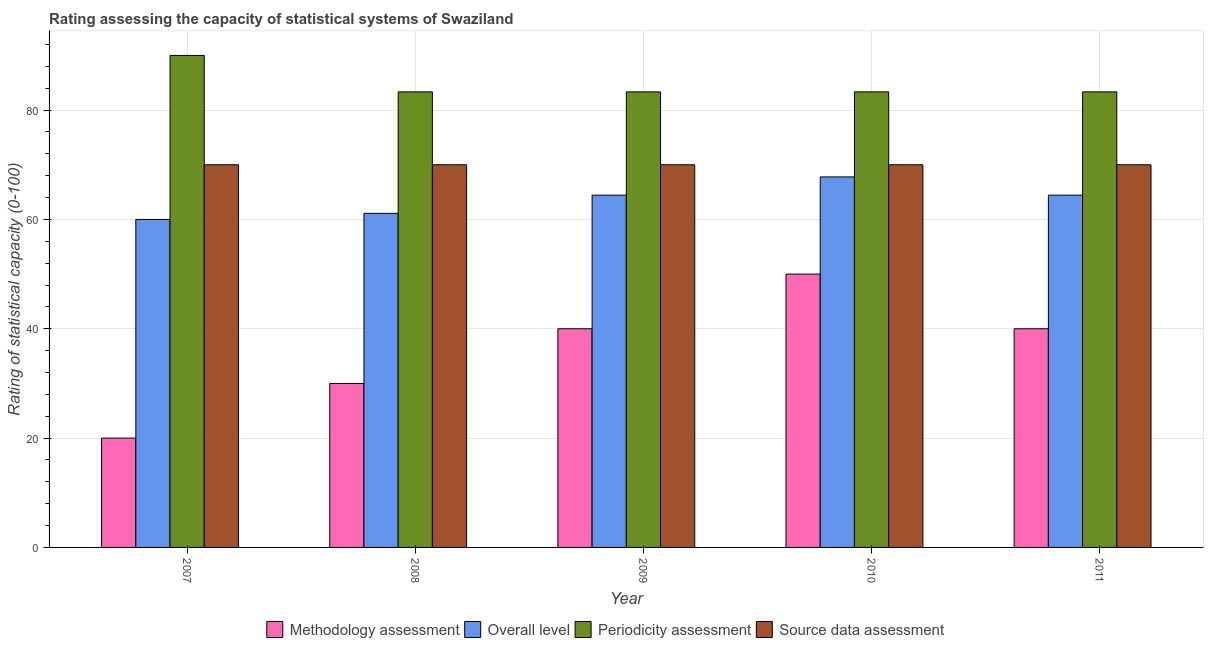How many groups of bars are there?
Ensure brevity in your answer.  5. Are the number of bars per tick equal to the number of legend labels?
Your response must be concise. Yes. How many bars are there on the 3rd tick from the left?
Ensure brevity in your answer.  4. How many bars are there on the 5th tick from the right?
Offer a terse response. 4. What is the label of the 2nd group of bars from the left?
Keep it short and to the point. 2008. What is the periodicity assessment rating in 2008?
Provide a short and direct response. 83.33. Across all years, what is the maximum overall level rating?
Make the answer very short. 67.78. Across all years, what is the minimum periodicity assessment rating?
Offer a very short reply. 83.33. In which year was the methodology assessment rating minimum?
Offer a very short reply. 2007. What is the total overall level rating in the graph?
Make the answer very short. 317.78. What is the difference between the overall level rating in 2008 and that in 2009?
Give a very brief answer. -3.33. In the year 2008, what is the difference between the source data assessment rating and overall level rating?
Offer a very short reply. 0. In how many years, is the methodology assessment rating greater than 52?
Your response must be concise. 0. What is the ratio of the overall level rating in 2009 to that in 2010?
Offer a terse response. 0.95. Is the methodology assessment rating in 2007 less than that in 2010?
Make the answer very short. Yes. Is the difference between the overall level rating in 2007 and 2009 greater than the difference between the methodology assessment rating in 2007 and 2009?
Provide a succinct answer. No. What is the difference between the highest and the second highest source data assessment rating?
Keep it short and to the point. 0. What is the difference between the highest and the lowest methodology assessment rating?
Provide a short and direct response. 30. In how many years, is the source data assessment rating greater than the average source data assessment rating taken over all years?
Ensure brevity in your answer.  0. What does the 2nd bar from the left in 2011 represents?
Make the answer very short. Overall level. What does the 1st bar from the right in 2008 represents?
Provide a succinct answer. Source data assessment. Is it the case that in every year, the sum of the methodology assessment rating and overall level rating is greater than the periodicity assessment rating?
Ensure brevity in your answer.  No. How many bars are there?
Your response must be concise. 20. Are all the bars in the graph horizontal?
Provide a short and direct response. No. How many years are there in the graph?
Give a very brief answer. 5. Does the graph contain any zero values?
Make the answer very short. No. Where does the legend appear in the graph?
Your response must be concise. Bottom center. How many legend labels are there?
Your response must be concise. 4. How are the legend labels stacked?
Give a very brief answer. Horizontal. What is the title of the graph?
Provide a succinct answer. Rating assessing the capacity of statistical systems of Swaziland. What is the label or title of the Y-axis?
Make the answer very short. Rating of statistical capacity (0-100). What is the Rating of statistical capacity (0-100) of Methodology assessment in 2007?
Ensure brevity in your answer.  20. What is the Rating of statistical capacity (0-100) of Overall level in 2007?
Offer a terse response. 60. What is the Rating of statistical capacity (0-100) in Methodology assessment in 2008?
Offer a very short reply. 30. What is the Rating of statistical capacity (0-100) of Overall level in 2008?
Your response must be concise. 61.11. What is the Rating of statistical capacity (0-100) of Periodicity assessment in 2008?
Your response must be concise. 83.33. What is the Rating of statistical capacity (0-100) in Overall level in 2009?
Make the answer very short. 64.44. What is the Rating of statistical capacity (0-100) of Periodicity assessment in 2009?
Provide a succinct answer. 83.33. What is the Rating of statistical capacity (0-100) of Source data assessment in 2009?
Your answer should be compact. 70. What is the Rating of statistical capacity (0-100) in Methodology assessment in 2010?
Give a very brief answer. 50. What is the Rating of statistical capacity (0-100) of Overall level in 2010?
Your answer should be very brief. 67.78. What is the Rating of statistical capacity (0-100) in Periodicity assessment in 2010?
Give a very brief answer. 83.33. What is the Rating of statistical capacity (0-100) in Source data assessment in 2010?
Make the answer very short. 70. What is the Rating of statistical capacity (0-100) in Overall level in 2011?
Offer a very short reply. 64.44. What is the Rating of statistical capacity (0-100) of Periodicity assessment in 2011?
Keep it short and to the point. 83.33. What is the Rating of statistical capacity (0-100) of Source data assessment in 2011?
Provide a short and direct response. 70. Across all years, what is the maximum Rating of statistical capacity (0-100) in Overall level?
Your answer should be compact. 67.78. Across all years, what is the minimum Rating of statistical capacity (0-100) of Overall level?
Provide a succinct answer. 60. Across all years, what is the minimum Rating of statistical capacity (0-100) in Periodicity assessment?
Make the answer very short. 83.33. Across all years, what is the minimum Rating of statistical capacity (0-100) of Source data assessment?
Keep it short and to the point. 70. What is the total Rating of statistical capacity (0-100) of Methodology assessment in the graph?
Keep it short and to the point. 180. What is the total Rating of statistical capacity (0-100) in Overall level in the graph?
Offer a terse response. 317.78. What is the total Rating of statistical capacity (0-100) in Periodicity assessment in the graph?
Ensure brevity in your answer.  423.33. What is the total Rating of statistical capacity (0-100) in Source data assessment in the graph?
Offer a terse response. 350. What is the difference between the Rating of statistical capacity (0-100) in Overall level in 2007 and that in 2008?
Give a very brief answer. -1.11. What is the difference between the Rating of statistical capacity (0-100) in Source data assessment in 2007 and that in 2008?
Provide a short and direct response. 0. What is the difference between the Rating of statistical capacity (0-100) of Methodology assessment in 2007 and that in 2009?
Offer a very short reply. -20. What is the difference between the Rating of statistical capacity (0-100) of Overall level in 2007 and that in 2009?
Your response must be concise. -4.44. What is the difference between the Rating of statistical capacity (0-100) in Periodicity assessment in 2007 and that in 2009?
Make the answer very short. 6.67. What is the difference between the Rating of statistical capacity (0-100) in Overall level in 2007 and that in 2010?
Your answer should be compact. -7.78. What is the difference between the Rating of statistical capacity (0-100) in Periodicity assessment in 2007 and that in 2010?
Your answer should be very brief. 6.67. What is the difference between the Rating of statistical capacity (0-100) in Source data assessment in 2007 and that in 2010?
Provide a short and direct response. 0. What is the difference between the Rating of statistical capacity (0-100) of Methodology assessment in 2007 and that in 2011?
Your answer should be compact. -20. What is the difference between the Rating of statistical capacity (0-100) in Overall level in 2007 and that in 2011?
Your response must be concise. -4.44. What is the difference between the Rating of statistical capacity (0-100) in Source data assessment in 2007 and that in 2011?
Offer a terse response. 0. What is the difference between the Rating of statistical capacity (0-100) of Overall level in 2008 and that in 2009?
Ensure brevity in your answer.  -3.33. What is the difference between the Rating of statistical capacity (0-100) of Periodicity assessment in 2008 and that in 2009?
Offer a very short reply. 0. What is the difference between the Rating of statistical capacity (0-100) in Methodology assessment in 2008 and that in 2010?
Provide a short and direct response. -20. What is the difference between the Rating of statistical capacity (0-100) of Overall level in 2008 and that in 2010?
Your answer should be very brief. -6.67. What is the difference between the Rating of statistical capacity (0-100) of Periodicity assessment in 2008 and that in 2010?
Offer a very short reply. 0. What is the difference between the Rating of statistical capacity (0-100) of Methodology assessment in 2008 and that in 2011?
Your answer should be very brief. -10. What is the difference between the Rating of statistical capacity (0-100) of Source data assessment in 2008 and that in 2011?
Ensure brevity in your answer.  0. What is the difference between the Rating of statistical capacity (0-100) of Source data assessment in 2009 and that in 2010?
Give a very brief answer. 0. What is the difference between the Rating of statistical capacity (0-100) of Overall level in 2009 and that in 2011?
Keep it short and to the point. 0. What is the difference between the Rating of statistical capacity (0-100) of Methodology assessment in 2010 and that in 2011?
Offer a very short reply. 10. What is the difference between the Rating of statistical capacity (0-100) in Overall level in 2010 and that in 2011?
Your answer should be very brief. 3.33. What is the difference between the Rating of statistical capacity (0-100) of Methodology assessment in 2007 and the Rating of statistical capacity (0-100) of Overall level in 2008?
Your response must be concise. -41.11. What is the difference between the Rating of statistical capacity (0-100) in Methodology assessment in 2007 and the Rating of statistical capacity (0-100) in Periodicity assessment in 2008?
Provide a succinct answer. -63.33. What is the difference between the Rating of statistical capacity (0-100) of Overall level in 2007 and the Rating of statistical capacity (0-100) of Periodicity assessment in 2008?
Keep it short and to the point. -23.33. What is the difference between the Rating of statistical capacity (0-100) of Overall level in 2007 and the Rating of statistical capacity (0-100) of Source data assessment in 2008?
Ensure brevity in your answer.  -10. What is the difference between the Rating of statistical capacity (0-100) in Periodicity assessment in 2007 and the Rating of statistical capacity (0-100) in Source data assessment in 2008?
Your answer should be compact. 20. What is the difference between the Rating of statistical capacity (0-100) of Methodology assessment in 2007 and the Rating of statistical capacity (0-100) of Overall level in 2009?
Provide a short and direct response. -44.44. What is the difference between the Rating of statistical capacity (0-100) in Methodology assessment in 2007 and the Rating of statistical capacity (0-100) in Periodicity assessment in 2009?
Offer a very short reply. -63.33. What is the difference between the Rating of statistical capacity (0-100) in Methodology assessment in 2007 and the Rating of statistical capacity (0-100) in Source data assessment in 2009?
Ensure brevity in your answer.  -50. What is the difference between the Rating of statistical capacity (0-100) of Overall level in 2007 and the Rating of statistical capacity (0-100) of Periodicity assessment in 2009?
Keep it short and to the point. -23.33. What is the difference between the Rating of statistical capacity (0-100) in Periodicity assessment in 2007 and the Rating of statistical capacity (0-100) in Source data assessment in 2009?
Your answer should be very brief. 20. What is the difference between the Rating of statistical capacity (0-100) in Methodology assessment in 2007 and the Rating of statistical capacity (0-100) in Overall level in 2010?
Your response must be concise. -47.78. What is the difference between the Rating of statistical capacity (0-100) of Methodology assessment in 2007 and the Rating of statistical capacity (0-100) of Periodicity assessment in 2010?
Make the answer very short. -63.33. What is the difference between the Rating of statistical capacity (0-100) of Overall level in 2007 and the Rating of statistical capacity (0-100) of Periodicity assessment in 2010?
Offer a very short reply. -23.33. What is the difference between the Rating of statistical capacity (0-100) of Periodicity assessment in 2007 and the Rating of statistical capacity (0-100) of Source data assessment in 2010?
Offer a terse response. 20. What is the difference between the Rating of statistical capacity (0-100) of Methodology assessment in 2007 and the Rating of statistical capacity (0-100) of Overall level in 2011?
Offer a terse response. -44.44. What is the difference between the Rating of statistical capacity (0-100) in Methodology assessment in 2007 and the Rating of statistical capacity (0-100) in Periodicity assessment in 2011?
Provide a short and direct response. -63.33. What is the difference between the Rating of statistical capacity (0-100) in Methodology assessment in 2007 and the Rating of statistical capacity (0-100) in Source data assessment in 2011?
Your answer should be very brief. -50. What is the difference between the Rating of statistical capacity (0-100) in Overall level in 2007 and the Rating of statistical capacity (0-100) in Periodicity assessment in 2011?
Your answer should be compact. -23.33. What is the difference between the Rating of statistical capacity (0-100) of Overall level in 2007 and the Rating of statistical capacity (0-100) of Source data assessment in 2011?
Your answer should be very brief. -10. What is the difference between the Rating of statistical capacity (0-100) of Methodology assessment in 2008 and the Rating of statistical capacity (0-100) of Overall level in 2009?
Give a very brief answer. -34.44. What is the difference between the Rating of statistical capacity (0-100) in Methodology assessment in 2008 and the Rating of statistical capacity (0-100) in Periodicity assessment in 2009?
Keep it short and to the point. -53.33. What is the difference between the Rating of statistical capacity (0-100) of Overall level in 2008 and the Rating of statistical capacity (0-100) of Periodicity assessment in 2009?
Offer a very short reply. -22.22. What is the difference between the Rating of statistical capacity (0-100) in Overall level in 2008 and the Rating of statistical capacity (0-100) in Source data assessment in 2009?
Your answer should be compact. -8.89. What is the difference between the Rating of statistical capacity (0-100) of Periodicity assessment in 2008 and the Rating of statistical capacity (0-100) of Source data assessment in 2009?
Your answer should be compact. 13.33. What is the difference between the Rating of statistical capacity (0-100) in Methodology assessment in 2008 and the Rating of statistical capacity (0-100) in Overall level in 2010?
Ensure brevity in your answer.  -37.78. What is the difference between the Rating of statistical capacity (0-100) in Methodology assessment in 2008 and the Rating of statistical capacity (0-100) in Periodicity assessment in 2010?
Offer a very short reply. -53.33. What is the difference between the Rating of statistical capacity (0-100) of Overall level in 2008 and the Rating of statistical capacity (0-100) of Periodicity assessment in 2010?
Your response must be concise. -22.22. What is the difference between the Rating of statistical capacity (0-100) of Overall level in 2008 and the Rating of statistical capacity (0-100) of Source data assessment in 2010?
Ensure brevity in your answer.  -8.89. What is the difference between the Rating of statistical capacity (0-100) in Periodicity assessment in 2008 and the Rating of statistical capacity (0-100) in Source data assessment in 2010?
Provide a succinct answer. 13.33. What is the difference between the Rating of statistical capacity (0-100) in Methodology assessment in 2008 and the Rating of statistical capacity (0-100) in Overall level in 2011?
Offer a very short reply. -34.44. What is the difference between the Rating of statistical capacity (0-100) in Methodology assessment in 2008 and the Rating of statistical capacity (0-100) in Periodicity assessment in 2011?
Ensure brevity in your answer.  -53.33. What is the difference between the Rating of statistical capacity (0-100) of Methodology assessment in 2008 and the Rating of statistical capacity (0-100) of Source data assessment in 2011?
Ensure brevity in your answer.  -40. What is the difference between the Rating of statistical capacity (0-100) in Overall level in 2008 and the Rating of statistical capacity (0-100) in Periodicity assessment in 2011?
Provide a succinct answer. -22.22. What is the difference between the Rating of statistical capacity (0-100) of Overall level in 2008 and the Rating of statistical capacity (0-100) of Source data assessment in 2011?
Offer a terse response. -8.89. What is the difference between the Rating of statistical capacity (0-100) in Periodicity assessment in 2008 and the Rating of statistical capacity (0-100) in Source data assessment in 2011?
Keep it short and to the point. 13.33. What is the difference between the Rating of statistical capacity (0-100) of Methodology assessment in 2009 and the Rating of statistical capacity (0-100) of Overall level in 2010?
Give a very brief answer. -27.78. What is the difference between the Rating of statistical capacity (0-100) of Methodology assessment in 2009 and the Rating of statistical capacity (0-100) of Periodicity assessment in 2010?
Offer a terse response. -43.33. What is the difference between the Rating of statistical capacity (0-100) of Overall level in 2009 and the Rating of statistical capacity (0-100) of Periodicity assessment in 2010?
Offer a terse response. -18.89. What is the difference between the Rating of statistical capacity (0-100) of Overall level in 2009 and the Rating of statistical capacity (0-100) of Source data assessment in 2010?
Provide a short and direct response. -5.56. What is the difference between the Rating of statistical capacity (0-100) in Periodicity assessment in 2009 and the Rating of statistical capacity (0-100) in Source data assessment in 2010?
Make the answer very short. 13.33. What is the difference between the Rating of statistical capacity (0-100) in Methodology assessment in 2009 and the Rating of statistical capacity (0-100) in Overall level in 2011?
Give a very brief answer. -24.44. What is the difference between the Rating of statistical capacity (0-100) of Methodology assessment in 2009 and the Rating of statistical capacity (0-100) of Periodicity assessment in 2011?
Offer a terse response. -43.33. What is the difference between the Rating of statistical capacity (0-100) in Overall level in 2009 and the Rating of statistical capacity (0-100) in Periodicity assessment in 2011?
Keep it short and to the point. -18.89. What is the difference between the Rating of statistical capacity (0-100) in Overall level in 2009 and the Rating of statistical capacity (0-100) in Source data assessment in 2011?
Ensure brevity in your answer.  -5.56. What is the difference between the Rating of statistical capacity (0-100) in Periodicity assessment in 2009 and the Rating of statistical capacity (0-100) in Source data assessment in 2011?
Provide a short and direct response. 13.33. What is the difference between the Rating of statistical capacity (0-100) of Methodology assessment in 2010 and the Rating of statistical capacity (0-100) of Overall level in 2011?
Provide a short and direct response. -14.44. What is the difference between the Rating of statistical capacity (0-100) in Methodology assessment in 2010 and the Rating of statistical capacity (0-100) in Periodicity assessment in 2011?
Your answer should be compact. -33.33. What is the difference between the Rating of statistical capacity (0-100) of Overall level in 2010 and the Rating of statistical capacity (0-100) of Periodicity assessment in 2011?
Your answer should be compact. -15.56. What is the difference between the Rating of statistical capacity (0-100) in Overall level in 2010 and the Rating of statistical capacity (0-100) in Source data assessment in 2011?
Your response must be concise. -2.22. What is the difference between the Rating of statistical capacity (0-100) in Periodicity assessment in 2010 and the Rating of statistical capacity (0-100) in Source data assessment in 2011?
Provide a succinct answer. 13.33. What is the average Rating of statistical capacity (0-100) in Methodology assessment per year?
Provide a succinct answer. 36. What is the average Rating of statistical capacity (0-100) of Overall level per year?
Offer a terse response. 63.56. What is the average Rating of statistical capacity (0-100) in Periodicity assessment per year?
Provide a short and direct response. 84.67. What is the average Rating of statistical capacity (0-100) in Source data assessment per year?
Your answer should be very brief. 70. In the year 2007, what is the difference between the Rating of statistical capacity (0-100) of Methodology assessment and Rating of statistical capacity (0-100) of Periodicity assessment?
Offer a terse response. -70. In the year 2007, what is the difference between the Rating of statistical capacity (0-100) in Overall level and Rating of statistical capacity (0-100) in Periodicity assessment?
Your answer should be compact. -30. In the year 2007, what is the difference between the Rating of statistical capacity (0-100) of Overall level and Rating of statistical capacity (0-100) of Source data assessment?
Your answer should be very brief. -10. In the year 2008, what is the difference between the Rating of statistical capacity (0-100) in Methodology assessment and Rating of statistical capacity (0-100) in Overall level?
Offer a very short reply. -31.11. In the year 2008, what is the difference between the Rating of statistical capacity (0-100) of Methodology assessment and Rating of statistical capacity (0-100) of Periodicity assessment?
Give a very brief answer. -53.33. In the year 2008, what is the difference between the Rating of statistical capacity (0-100) in Overall level and Rating of statistical capacity (0-100) in Periodicity assessment?
Make the answer very short. -22.22. In the year 2008, what is the difference between the Rating of statistical capacity (0-100) in Overall level and Rating of statistical capacity (0-100) in Source data assessment?
Offer a very short reply. -8.89. In the year 2008, what is the difference between the Rating of statistical capacity (0-100) in Periodicity assessment and Rating of statistical capacity (0-100) in Source data assessment?
Offer a terse response. 13.33. In the year 2009, what is the difference between the Rating of statistical capacity (0-100) in Methodology assessment and Rating of statistical capacity (0-100) in Overall level?
Your response must be concise. -24.44. In the year 2009, what is the difference between the Rating of statistical capacity (0-100) of Methodology assessment and Rating of statistical capacity (0-100) of Periodicity assessment?
Provide a short and direct response. -43.33. In the year 2009, what is the difference between the Rating of statistical capacity (0-100) of Overall level and Rating of statistical capacity (0-100) of Periodicity assessment?
Ensure brevity in your answer.  -18.89. In the year 2009, what is the difference between the Rating of statistical capacity (0-100) of Overall level and Rating of statistical capacity (0-100) of Source data assessment?
Your response must be concise. -5.56. In the year 2009, what is the difference between the Rating of statistical capacity (0-100) of Periodicity assessment and Rating of statistical capacity (0-100) of Source data assessment?
Make the answer very short. 13.33. In the year 2010, what is the difference between the Rating of statistical capacity (0-100) in Methodology assessment and Rating of statistical capacity (0-100) in Overall level?
Offer a very short reply. -17.78. In the year 2010, what is the difference between the Rating of statistical capacity (0-100) in Methodology assessment and Rating of statistical capacity (0-100) in Periodicity assessment?
Offer a terse response. -33.33. In the year 2010, what is the difference between the Rating of statistical capacity (0-100) in Overall level and Rating of statistical capacity (0-100) in Periodicity assessment?
Your response must be concise. -15.56. In the year 2010, what is the difference between the Rating of statistical capacity (0-100) in Overall level and Rating of statistical capacity (0-100) in Source data assessment?
Your answer should be compact. -2.22. In the year 2010, what is the difference between the Rating of statistical capacity (0-100) in Periodicity assessment and Rating of statistical capacity (0-100) in Source data assessment?
Ensure brevity in your answer.  13.33. In the year 2011, what is the difference between the Rating of statistical capacity (0-100) in Methodology assessment and Rating of statistical capacity (0-100) in Overall level?
Provide a short and direct response. -24.44. In the year 2011, what is the difference between the Rating of statistical capacity (0-100) in Methodology assessment and Rating of statistical capacity (0-100) in Periodicity assessment?
Offer a terse response. -43.33. In the year 2011, what is the difference between the Rating of statistical capacity (0-100) in Methodology assessment and Rating of statistical capacity (0-100) in Source data assessment?
Make the answer very short. -30. In the year 2011, what is the difference between the Rating of statistical capacity (0-100) in Overall level and Rating of statistical capacity (0-100) in Periodicity assessment?
Make the answer very short. -18.89. In the year 2011, what is the difference between the Rating of statistical capacity (0-100) of Overall level and Rating of statistical capacity (0-100) of Source data assessment?
Provide a short and direct response. -5.56. In the year 2011, what is the difference between the Rating of statistical capacity (0-100) in Periodicity assessment and Rating of statistical capacity (0-100) in Source data assessment?
Your answer should be compact. 13.33. What is the ratio of the Rating of statistical capacity (0-100) of Overall level in 2007 to that in 2008?
Your response must be concise. 0.98. What is the ratio of the Rating of statistical capacity (0-100) of Periodicity assessment in 2007 to that in 2008?
Offer a very short reply. 1.08. What is the ratio of the Rating of statistical capacity (0-100) of Source data assessment in 2007 to that in 2008?
Keep it short and to the point. 1. What is the ratio of the Rating of statistical capacity (0-100) in Overall level in 2007 to that in 2009?
Make the answer very short. 0.93. What is the ratio of the Rating of statistical capacity (0-100) of Periodicity assessment in 2007 to that in 2009?
Keep it short and to the point. 1.08. What is the ratio of the Rating of statistical capacity (0-100) in Source data assessment in 2007 to that in 2009?
Your response must be concise. 1. What is the ratio of the Rating of statistical capacity (0-100) in Overall level in 2007 to that in 2010?
Your response must be concise. 0.89. What is the ratio of the Rating of statistical capacity (0-100) in Periodicity assessment in 2007 to that in 2010?
Offer a terse response. 1.08. What is the ratio of the Rating of statistical capacity (0-100) in Methodology assessment in 2007 to that in 2011?
Make the answer very short. 0.5. What is the ratio of the Rating of statistical capacity (0-100) of Source data assessment in 2007 to that in 2011?
Your answer should be compact. 1. What is the ratio of the Rating of statistical capacity (0-100) of Methodology assessment in 2008 to that in 2009?
Your response must be concise. 0.75. What is the ratio of the Rating of statistical capacity (0-100) in Overall level in 2008 to that in 2009?
Make the answer very short. 0.95. What is the ratio of the Rating of statistical capacity (0-100) in Periodicity assessment in 2008 to that in 2009?
Ensure brevity in your answer.  1. What is the ratio of the Rating of statistical capacity (0-100) of Source data assessment in 2008 to that in 2009?
Offer a terse response. 1. What is the ratio of the Rating of statistical capacity (0-100) in Overall level in 2008 to that in 2010?
Offer a terse response. 0.9. What is the ratio of the Rating of statistical capacity (0-100) in Periodicity assessment in 2008 to that in 2010?
Offer a very short reply. 1. What is the ratio of the Rating of statistical capacity (0-100) of Methodology assessment in 2008 to that in 2011?
Keep it short and to the point. 0.75. What is the ratio of the Rating of statistical capacity (0-100) in Overall level in 2008 to that in 2011?
Provide a short and direct response. 0.95. What is the ratio of the Rating of statistical capacity (0-100) of Periodicity assessment in 2008 to that in 2011?
Your response must be concise. 1. What is the ratio of the Rating of statistical capacity (0-100) in Source data assessment in 2008 to that in 2011?
Provide a succinct answer. 1. What is the ratio of the Rating of statistical capacity (0-100) in Overall level in 2009 to that in 2010?
Provide a short and direct response. 0.95. What is the ratio of the Rating of statistical capacity (0-100) of Periodicity assessment in 2009 to that in 2010?
Your response must be concise. 1. What is the ratio of the Rating of statistical capacity (0-100) in Overall level in 2009 to that in 2011?
Make the answer very short. 1. What is the ratio of the Rating of statistical capacity (0-100) in Source data assessment in 2009 to that in 2011?
Provide a short and direct response. 1. What is the ratio of the Rating of statistical capacity (0-100) of Overall level in 2010 to that in 2011?
Make the answer very short. 1.05. What is the ratio of the Rating of statistical capacity (0-100) of Source data assessment in 2010 to that in 2011?
Offer a terse response. 1. What is the difference between the highest and the second highest Rating of statistical capacity (0-100) of Methodology assessment?
Your answer should be compact. 10. What is the difference between the highest and the lowest Rating of statistical capacity (0-100) of Methodology assessment?
Make the answer very short. 30. What is the difference between the highest and the lowest Rating of statistical capacity (0-100) in Overall level?
Ensure brevity in your answer.  7.78. What is the difference between the highest and the lowest Rating of statistical capacity (0-100) in Periodicity assessment?
Provide a succinct answer. 6.67. 